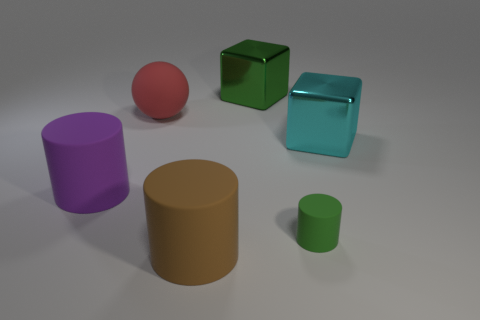Subtract all large matte cylinders. How many cylinders are left? 1 Subtract all cubes. How many objects are left? 4 Subtract 2 cylinders. How many cylinders are left? 1 Add 5 big matte cylinders. How many big matte cylinders exist? 7 Add 2 small green cylinders. How many objects exist? 8 Subtract all purple cylinders. How many cylinders are left? 2 Subtract 0 red cylinders. How many objects are left? 6 Subtract all red cylinders. Subtract all red balls. How many cylinders are left? 3 Subtract all gray cubes. How many yellow cylinders are left? 0 Subtract all small green rubber cylinders. Subtract all large green metal objects. How many objects are left? 4 